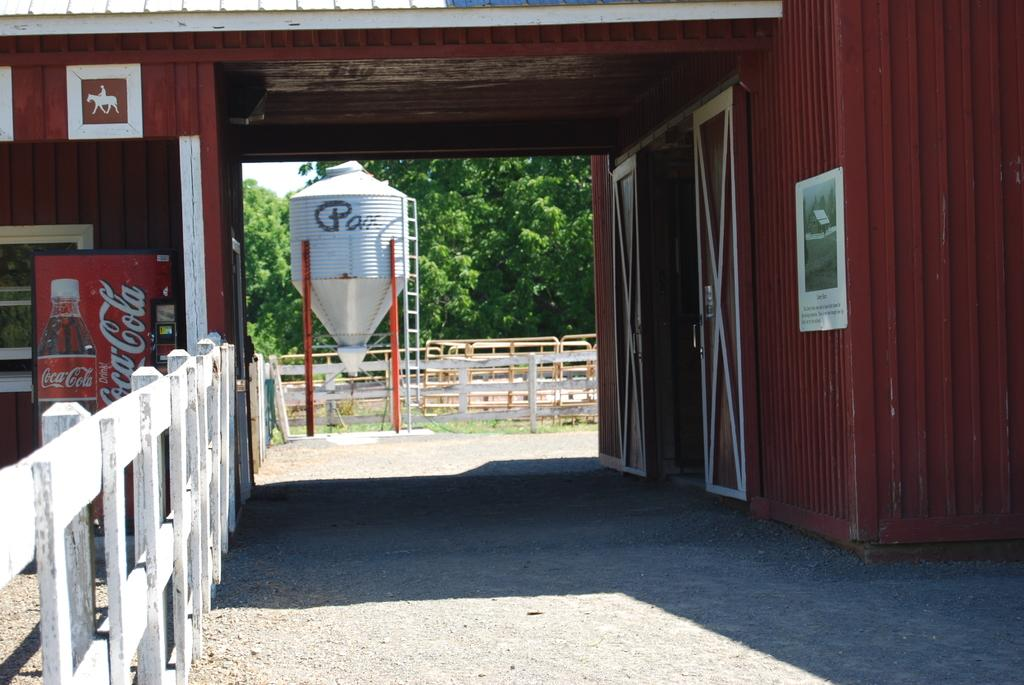What type of structure is visible in the image? There is a building in the image. What is attached to the building? There is a poster on the building. What appliance can be seen in the image? There is a refrigerator in the image. What type of container is present in the image? There is a tank in the image. What feature allows access to the building? There are doors in the image. What type of barrier is visible in the image? There is a fence in the image. What type of vegetation is present in the image? There are trees in the image. How many friends are playing with the pickle in the wilderness in the image? There is no pickle or friends playing in the wilderness in the image. 